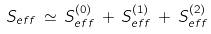<formula> <loc_0><loc_0><loc_500><loc_500>S _ { e f f } \, \simeq \, S _ { e f f } ^ { ( 0 ) } \, + \, S _ { e f f } ^ { ( 1 ) } \, + \, S _ { e f f } ^ { ( 2 ) }</formula> 